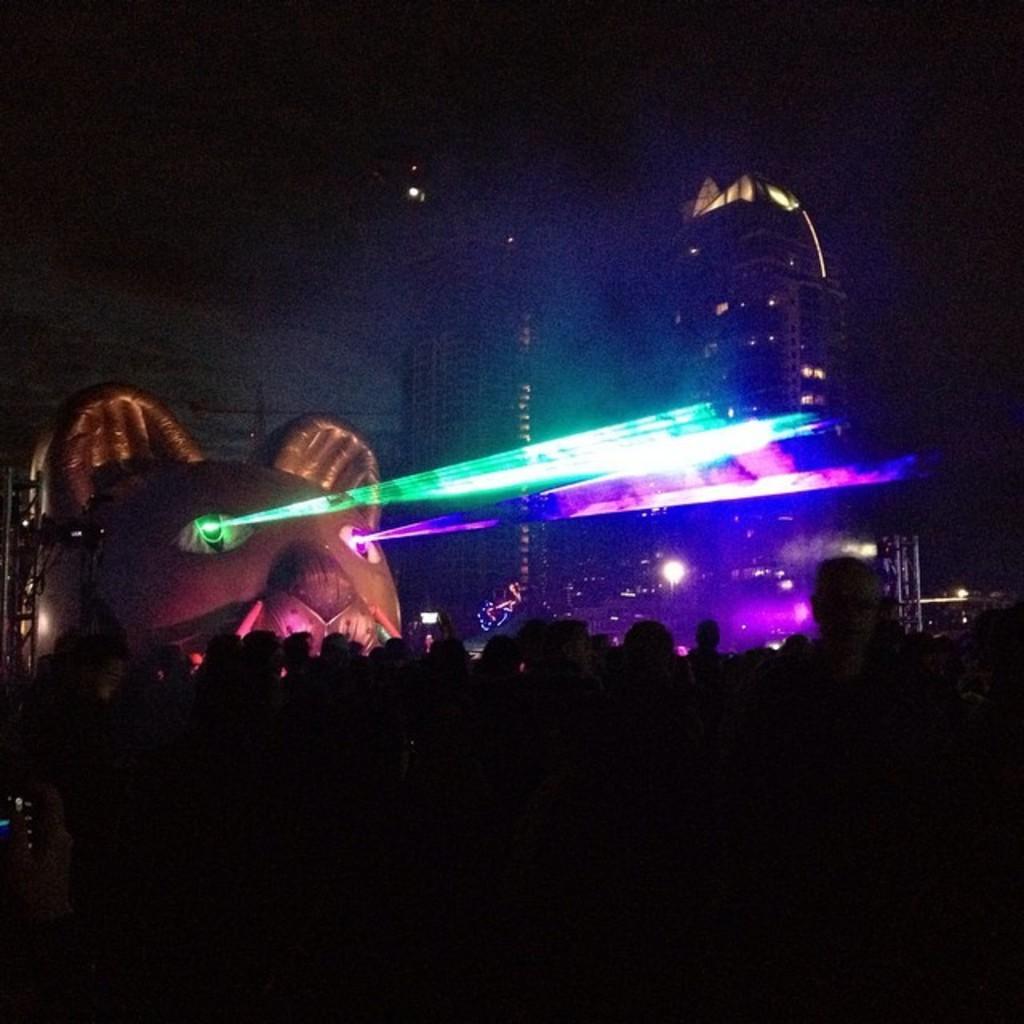How would you summarize this image in a sentence or two? In this image we can see a statue with some lights. We can also see a group of people and some buildings with windows. 